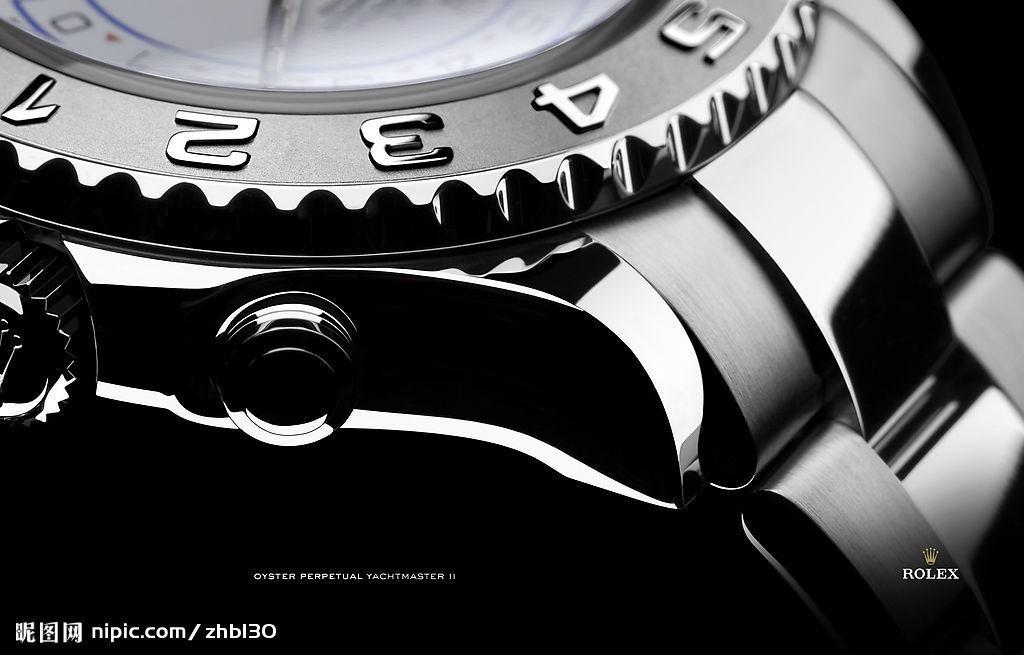What luxury watch brand is being advertised?
Offer a very short reply. Rolex. What hour is it?
Offer a terse response. 2. 